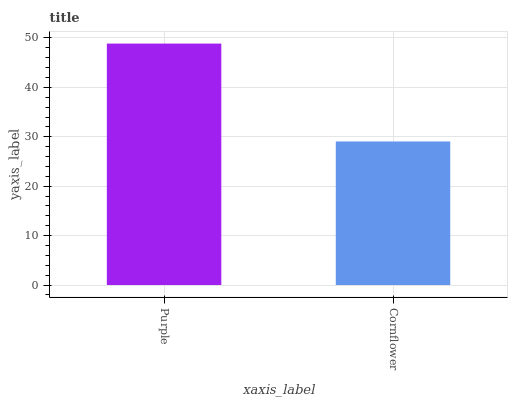Is Cornflower the maximum?
Answer yes or no. No. Is Purple greater than Cornflower?
Answer yes or no. Yes. Is Cornflower less than Purple?
Answer yes or no. Yes. Is Cornflower greater than Purple?
Answer yes or no. No. Is Purple less than Cornflower?
Answer yes or no. No. Is Purple the high median?
Answer yes or no. Yes. Is Cornflower the low median?
Answer yes or no. Yes. Is Cornflower the high median?
Answer yes or no. No. Is Purple the low median?
Answer yes or no. No. 